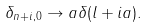Convert formula to latex. <formula><loc_0><loc_0><loc_500><loc_500>\delta _ { n + i , 0 } \rightarrow a \delta ( l + i a ) .</formula> 